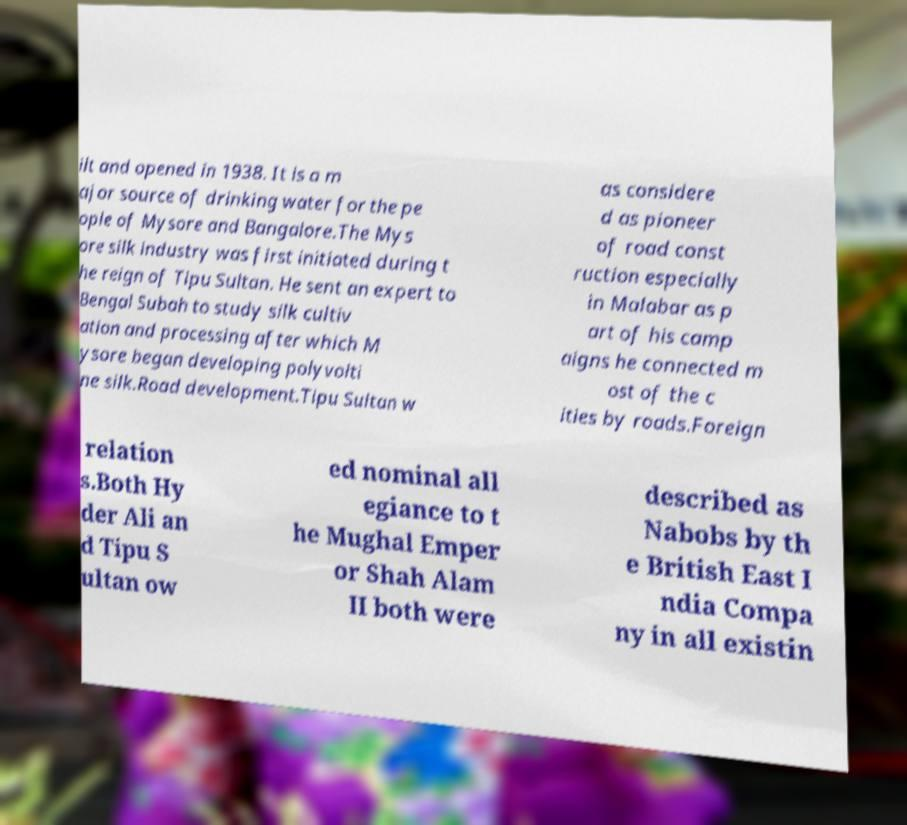Please read and relay the text visible in this image. What does it say? ilt and opened in 1938. It is a m ajor source of drinking water for the pe ople of Mysore and Bangalore.The Mys ore silk industry was first initiated during t he reign of Tipu Sultan. He sent an expert to Bengal Subah to study silk cultiv ation and processing after which M ysore began developing polyvolti ne silk.Road development.Tipu Sultan w as considere d as pioneer of road const ruction especially in Malabar as p art of his camp aigns he connected m ost of the c ities by roads.Foreign relation s.Both Hy der Ali an d Tipu S ultan ow ed nominal all egiance to t he Mughal Emper or Shah Alam II both were described as Nabobs by th e British East I ndia Compa ny in all existin 